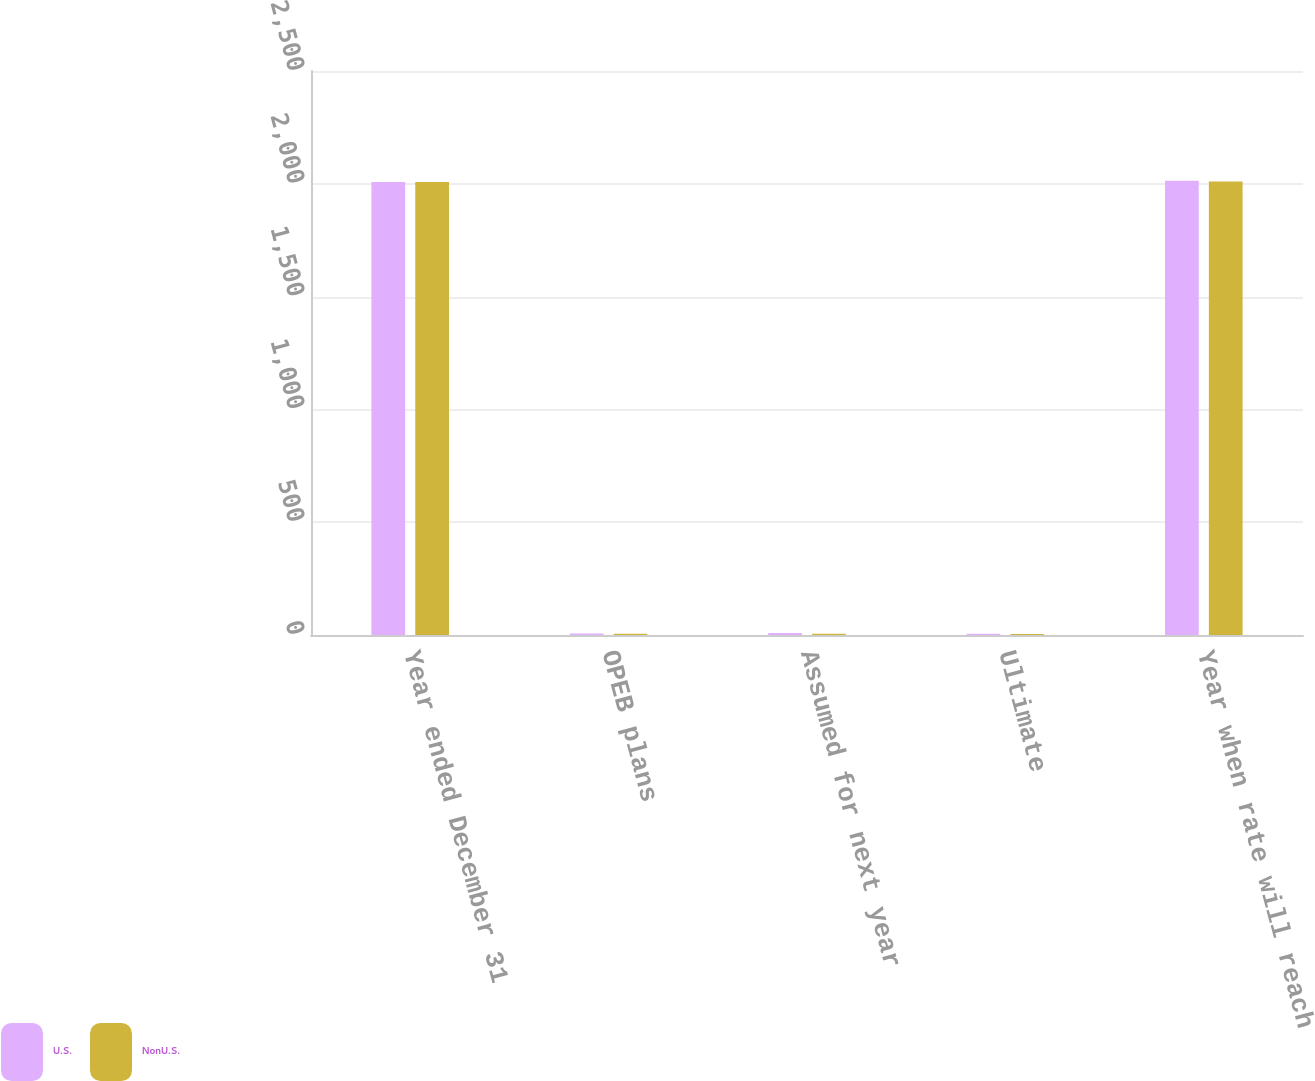Convert chart. <chart><loc_0><loc_0><loc_500><loc_500><stacked_bar_chart><ecel><fcel>Year ended December 31<fcel>OPEB plans<fcel>Assumed for next year<fcel>Ultimate<fcel>Year when rate will reach<nl><fcel>U.S.<fcel>2008<fcel>6.6<fcel>9.25<fcel>5<fcel>2014<nl><fcel>NonU.S.<fcel>2008<fcel>5.8<fcel>5.75<fcel>4<fcel>2010<nl></chart> 